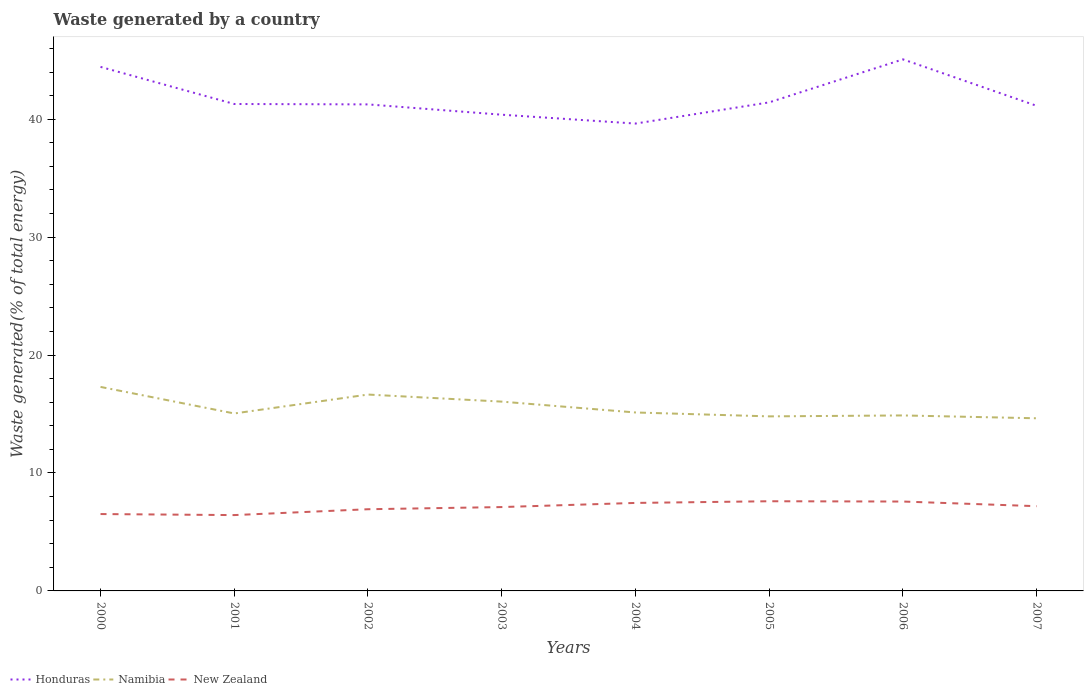How many different coloured lines are there?
Provide a succinct answer. 3. Is the number of lines equal to the number of legend labels?
Keep it short and to the point. Yes. Across all years, what is the maximum total waste generated in Honduras?
Offer a very short reply. 39.63. What is the total total waste generated in New Zealand in the graph?
Your response must be concise. -0.68. What is the difference between the highest and the second highest total waste generated in Honduras?
Ensure brevity in your answer.  5.44. What is the difference between the highest and the lowest total waste generated in Honduras?
Your answer should be very brief. 2. What is the difference between two consecutive major ticks on the Y-axis?
Offer a very short reply. 10. How are the legend labels stacked?
Your response must be concise. Horizontal. What is the title of the graph?
Make the answer very short. Waste generated by a country. Does "Marshall Islands" appear as one of the legend labels in the graph?
Your answer should be compact. No. What is the label or title of the X-axis?
Your response must be concise. Years. What is the label or title of the Y-axis?
Make the answer very short. Waste generated(% of total energy). What is the Waste generated(% of total energy) in Honduras in 2000?
Provide a succinct answer. 44.44. What is the Waste generated(% of total energy) of Namibia in 2000?
Provide a succinct answer. 17.3. What is the Waste generated(% of total energy) of New Zealand in 2000?
Your response must be concise. 6.52. What is the Waste generated(% of total energy) of Honduras in 2001?
Provide a succinct answer. 41.29. What is the Waste generated(% of total energy) of Namibia in 2001?
Offer a very short reply. 15.05. What is the Waste generated(% of total energy) in New Zealand in 2001?
Your response must be concise. 6.43. What is the Waste generated(% of total energy) of Honduras in 2002?
Give a very brief answer. 41.26. What is the Waste generated(% of total energy) of Namibia in 2002?
Make the answer very short. 16.65. What is the Waste generated(% of total energy) of New Zealand in 2002?
Ensure brevity in your answer.  6.93. What is the Waste generated(% of total energy) of Honduras in 2003?
Ensure brevity in your answer.  40.38. What is the Waste generated(% of total energy) of Namibia in 2003?
Your answer should be compact. 16.05. What is the Waste generated(% of total energy) of New Zealand in 2003?
Make the answer very short. 7.11. What is the Waste generated(% of total energy) in Honduras in 2004?
Ensure brevity in your answer.  39.63. What is the Waste generated(% of total energy) of Namibia in 2004?
Provide a succinct answer. 15.13. What is the Waste generated(% of total energy) in New Zealand in 2004?
Provide a succinct answer. 7.46. What is the Waste generated(% of total energy) in Honduras in 2005?
Offer a terse response. 41.43. What is the Waste generated(% of total energy) in Namibia in 2005?
Provide a short and direct response. 14.8. What is the Waste generated(% of total energy) of New Zealand in 2005?
Your answer should be very brief. 7.6. What is the Waste generated(% of total energy) of Honduras in 2006?
Keep it short and to the point. 45.07. What is the Waste generated(% of total energy) in Namibia in 2006?
Offer a terse response. 14.88. What is the Waste generated(% of total energy) in New Zealand in 2006?
Your answer should be compact. 7.58. What is the Waste generated(% of total energy) of Honduras in 2007?
Keep it short and to the point. 41.13. What is the Waste generated(% of total energy) of Namibia in 2007?
Provide a short and direct response. 14.64. What is the Waste generated(% of total energy) in New Zealand in 2007?
Your answer should be very brief. 7.19. Across all years, what is the maximum Waste generated(% of total energy) in Honduras?
Your response must be concise. 45.07. Across all years, what is the maximum Waste generated(% of total energy) of Namibia?
Your response must be concise. 17.3. Across all years, what is the maximum Waste generated(% of total energy) in New Zealand?
Offer a very short reply. 7.6. Across all years, what is the minimum Waste generated(% of total energy) in Honduras?
Provide a succinct answer. 39.63. Across all years, what is the minimum Waste generated(% of total energy) in Namibia?
Give a very brief answer. 14.64. Across all years, what is the minimum Waste generated(% of total energy) in New Zealand?
Offer a terse response. 6.43. What is the total Waste generated(% of total energy) of Honduras in the graph?
Provide a short and direct response. 334.63. What is the total Waste generated(% of total energy) of Namibia in the graph?
Your answer should be very brief. 124.5. What is the total Waste generated(% of total energy) of New Zealand in the graph?
Keep it short and to the point. 56.82. What is the difference between the Waste generated(% of total energy) of Honduras in 2000 and that in 2001?
Your response must be concise. 3.15. What is the difference between the Waste generated(% of total energy) in Namibia in 2000 and that in 2001?
Make the answer very short. 2.25. What is the difference between the Waste generated(% of total energy) of New Zealand in 2000 and that in 2001?
Provide a short and direct response. 0.09. What is the difference between the Waste generated(% of total energy) in Honduras in 2000 and that in 2002?
Offer a very short reply. 3.18. What is the difference between the Waste generated(% of total energy) in Namibia in 2000 and that in 2002?
Offer a very short reply. 0.65. What is the difference between the Waste generated(% of total energy) of New Zealand in 2000 and that in 2002?
Provide a short and direct response. -0.41. What is the difference between the Waste generated(% of total energy) of Honduras in 2000 and that in 2003?
Offer a terse response. 4.05. What is the difference between the Waste generated(% of total energy) in Namibia in 2000 and that in 2003?
Offer a very short reply. 1.25. What is the difference between the Waste generated(% of total energy) in New Zealand in 2000 and that in 2003?
Your response must be concise. -0.59. What is the difference between the Waste generated(% of total energy) in Honduras in 2000 and that in 2004?
Your answer should be very brief. 4.81. What is the difference between the Waste generated(% of total energy) in Namibia in 2000 and that in 2004?
Offer a terse response. 2.17. What is the difference between the Waste generated(% of total energy) of New Zealand in 2000 and that in 2004?
Your response must be concise. -0.94. What is the difference between the Waste generated(% of total energy) in Honduras in 2000 and that in 2005?
Provide a short and direct response. 3.01. What is the difference between the Waste generated(% of total energy) in Namibia in 2000 and that in 2005?
Provide a short and direct response. 2.5. What is the difference between the Waste generated(% of total energy) in New Zealand in 2000 and that in 2005?
Offer a terse response. -1.09. What is the difference between the Waste generated(% of total energy) of Honduras in 2000 and that in 2006?
Your answer should be compact. -0.64. What is the difference between the Waste generated(% of total energy) of Namibia in 2000 and that in 2006?
Your answer should be compact. 2.42. What is the difference between the Waste generated(% of total energy) of New Zealand in 2000 and that in 2006?
Ensure brevity in your answer.  -1.06. What is the difference between the Waste generated(% of total energy) in Honduras in 2000 and that in 2007?
Provide a short and direct response. 3.3. What is the difference between the Waste generated(% of total energy) of Namibia in 2000 and that in 2007?
Offer a terse response. 2.66. What is the difference between the Waste generated(% of total energy) of New Zealand in 2000 and that in 2007?
Give a very brief answer. -0.67. What is the difference between the Waste generated(% of total energy) in Honduras in 2001 and that in 2002?
Ensure brevity in your answer.  0.03. What is the difference between the Waste generated(% of total energy) of Namibia in 2001 and that in 2002?
Ensure brevity in your answer.  -1.6. What is the difference between the Waste generated(% of total energy) of New Zealand in 2001 and that in 2002?
Your response must be concise. -0.5. What is the difference between the Waste generated(% of total energy) in Honduras in 2001 and that in 2003?
Make the answer very short. 0.91. What is the difference between the Waste generated(% of total energy) of Namibia in 2001 and that in 2003?
Your answer should be compact. -1. What is the difference between the Waste generated(% of total energy) of New Zealand in 2001 and that in 2003?
Provide a succinct answer. -0.68. What is the difference between the Waste generated(% of total energy) of Honduras in 2001 and that in 2004?
Keep it short and to the point. 1.66. What is the difference between the Waste generated(% of total energy) of Namibia in 2001 and that in 2004?
Keep it short and to the point. -0.08. What is the difference between the Waste generated(% of total energy) in New Zealand in 2001 and that in 2004?
Make the answer very short. -1.03. What is the difference between the Waste generated(% of total energy) in Honduras in 2001 and that in 2005?
Ensure brevity in your answer.  -0.14. What is the difference between the Waste generated(% of total energy) of Namibia in 2001 and that in 2005?
Offer a terse response. 0.25. What is the difference between the Waste generated(% of total energy) of New Zealand in 2001 and that in 2005?
Offer a very short reply. -1.17. What is the difference between the Waste generated(% of total energy) of Honduras in 2001 and that in 2006?
Keep it short and to the point. -3.78. What is the difference between the Waste generated(% of total energy) in Namibia in 2001 and that in 2006?
Your response must be concise. 0.17. What is the difference between the Waste generated(% of total energy) of New Zealand in 2001 and that in 2006?
Provide a short and direct response. -1.15. What is the difference between the Waste generated(% of total energy) in Honduras in 2001 and that in 2007?
Give a very brief answer. 0.16. What is the difference between the Waste generated(% of total energy) of Namibia in 2001 and that in 2007?
Keep it short and to the point. 0.41. What is the difference between the Waste generated(% of total energy) in New Zealand in 2001 and that in 2007?
Offer a very short reply. -0.76. What is the difference between the Waste generated(% of total energy) of Honduras in 2002 and that in 2003?
Provide a succinct answer. 0.87. What is the difference between the Waste generated(% of total energy) of Namibia in 2002 and that in 2003?
Provide a short and direct response. 0.6. What is the difference between the Waste generated(% of total energy) in New Zealand in 2002 and that in 2003?
Give a very brief answer. -0.18. What is the difference between the Waste generated(% of total energy) in Honduras in 2002 and that in 2004?
Your response must be concise. 1.63. What is the difference between the Waste generated(% of total energy) in Namibia in 2002 and that in 2004?
Provide a short and direct response. 1.52. What is the difference between the Waste generated(% of total energy) in New Zealand in 2002 and that in 2004?
Offer a very short reply. -0.53. What is the difference between the Waste generated(% of total energy) in Honduras in 2002 and that in 2005?
Ensure brevity in your answer.  -0.17. What is the difference between the Waste generated(% of total energy) in Namibia in 2002 and that in 2005?
Offer a terse response. 1.85. What is the difference between the Waste generated(% of total energy) in New Zealand in 2002 and that in 2005?
Keep it short and to the point. -0.68. What is the difference between the Waste generated(% of total energy) in Honduras in 2002 and that in 2006?
Offer a very short reply. -3.82. What is the difference between the Waste generated(% of total energy) of Namibia in 2002 and that in 2006?
Provide a succinct answer. 1.77. What is the difference between the Waste generated(% of total energy) of New Zealand in 2002 and that in 2006?
Provide a short and direct response. -0.65. What is the difference between the Waste generated(% of total energy) in Honduras in 2002 and that in 2007?
Provide a short and direct response. 0.12. What is the difference between the Waste generated(% of total energy) in Namibia in 2002 and that in 2007?
Keep it short and to the point. 2.01. What is the difference between the Waste generated(% of total energy) in New Zealand in 2002 and that in 2007?
Ensure brevity in your answer.  -0.26. What is the difference between the Waste generated(% of total energy) of Honduras in 2003 and that in 2004?
Offer a very short reply. 0.75. What is the difference between the Waste generated(% of total energy) of Namibia in 2003 and that in 2004?
Offer a very short reply. 0.92. What is the difference between the Waste generated(% of total energy) in New Zealand in 2003 and that in 2004?
Your answer should be compact. -0.35. What is the difference between the Waste generated(% of total energy) of Honduras in 2003 and that in 2005?
Make the answer very short. -1.05. What is the difference between the Waste generated(% of total energy) in Namibia in 2003 and that in 2005?
Provide a succinct answer. 1.25. What is the difference between the Waste generated(% of total energy) of New Zealand in 2003 and that in 2005?
Make the answer very short. -0.49. What is the difference between the Waste generated(% of total energy) of Honduras in 2003 and that in 2006?
Your answer should be very brief. -4.69. What is the difference between the Waste generated(% of total energy) in Namibia in 2003 and that in 2006?
Your answer should be compact. 1.17. What is the difference between the Waste generated(% of total energy) of New Zealand in 2003 and that in 2006?
Your answer should be very brief. -0.47. What is the difference between the Waste generated(% of total energy) of Honduras in 2003 and that in 2007?
Give a very brief answer. -0.75. What is the difference between the Waste generated(% of total energy) in Namibia in 2003 and that in 2007?
Your response must be concise. 1.41. What is the difference between the Waste generated(% of total energy) in New Zealand in 2003 and that in 2007?
Ensure brevity in your answer.  -0.07. What is the difference between the Waste generated(% of total energy) of Honduras in 2004 and that in 2005?
Your answer should be compact. -1.8. What is the difference between the Waste generated(% of total energy) of Namibia in 2004 and that in 2005?
Your response must be concise. 0.33. What is the difference between the Waste generated(% of total energy) of New Zealand in 2004 and that in 2005?
Keep it short and to the point. -0.14. What is the difference between the Waste generated(% of total energy) in Honduras in 2004 and that in 2006?
Keep it short and to the point. -5.44. What is the difference between the Waste generated(% of total energy) in Namibia in 2004 and that in 2006?
Make the answer very short. 0.25. What is the difference between the Waste generated(% of total energy) in New Zealand in 2004 and that in 2006?
Offer a terse response. -0.12. What is the difference between the Waste generated(% of total energy) in Honduras in 2004 and that in 2007?
Make the answer very short. -1.5. What is the difference between the Waste generated(% of total energy) of Namibia in 2004 and that in 2007?
Your answer should be very brief. 0.49. What is the difference between the Waste generated(% of total energy) in New Zealand in 2004 and that in 2007?
Provide a succinct answer. 0.28. What is the difference between the Waste generated(% of total energy) in Honduras in 2005 and that in 2006?
Keep it short and to the point. -3.65. What is the difference between the Waste generated(% of total energy) of Namibia in 2005 and that in 2006?
Offer a terse response. -0.08. What is the difference between the Waste generated(% of total energy) of New Zealand in 2005 and that in 2006?
Keep it short and to the point. 0.02. What is the difference between the Waste generated(% of total energy) in Honduras in 2005 and that in 2007?
Provide a succinct answer. 0.29. What is the difference between the Waste generated(% of total energy) of Namibia in 2005 and that in 2007?
Your answer should be compact. 0.16. What is the difference between the Waste generated(% of total energy) of New Zealand in 2005 and that in 2007?
Ensure brevity in your answer.  0.42. What is the difference between the Waste generated(% of total energy) of Honduras in 2006 and that in 2007?
Ensure brevity in your answer.  3.94. What is the difference between the Waste generated(% of total energy) of Namibia in 2006 and that in 2007?
Make the answer very short. 0.24. What is the difference between the Waste generated(% of total energy) in New Zealand in 2006 and that in 2007?
Keep it short and to the point. 0.39. What is the difference between the Waste generated(% of total energy) of Honduras in 2000 and the Waste generated(% of total energy) of Namibia in 2001?
Make the answer very short. 29.39. What is the difference between the Waste generated(% of total energy) of Honduras in 2000 and the Waste generated(% of total energy) of New Zealand in 2001?
Your answer should be compact. 38.01. What is the difference between the Waste generated(% of total energy) in Namibia in 2000 and the Waste generated(% of total energy) in New Zealand in 2001?
Your answer should be compact. 10.87. What is the difference between the Waste generated(% of total energy) of Honduras in 2000 and the Waste generated(% of total energy) of Namibia in 2002?
Offer a terse response. 27.78. What is the difference between the Waste generated(% of total energy) in Honduras in 2000 and the Waste generated(% of total energy) in New Zealand in 2002?
Your answer should be compact. 37.51. What is the difference between the Waste generated(% of total energy) in Namibia in 2000 and the Waste generated(% of total energy) in New Zealand in 2002?
Make the answer very short. 10.37. What is the difference between the Waste generated(% of total energy) in Honduras in 2000 and the Waste generated(% of total energy) in Namibia in 2003?
Offer a terse response. 28.38. What is the difference between the Waste generated(% of total energy) of Honduras in 2000 and the Waste generated(% of total energy) of New Zealand in 2003?
Your answer should be compact. 37.33. What is the difference between the Waste generated(% of total energy) in Namibia in 2000 and the Waste generated(% of total energy) in New Zealand in 2003?
Give a very brief answer. 10.19. What is the difference between the Waste generated(% of total energy) in Honduras in 2000 and the Waste generated(% of total energy) in Namibia in 2004?
Make the answer very short. 29.3. What is the difference between the Waste generated(% of total energy) of Honduras in 2000 and the Waste generated(% of total energy) of New Zealand in 2004?
Make the answer very short. 36.97. What is the difference between the Waste generated(% of total energy) in Namibia in 2000 and the Waste generated(% of total energy) in New Zealand in 2004?
Make the answer very short. 9.84. What is the difference between the Waste generated(% of total energy) in Honduras in 2000 and the Waste generated(% of total energy) in Namibia in 2005?
Give a very brief answer. 29.64. What is the difference between the Waste generated(% of total energy) of Honduras in 2000 and the Waste generated(% of total energy) of New Zealand in 2005?
Provide a short and direct response. 36.83. What is the difference between the Waste generated(% of total energy) of Namibia in 2000 and the Waste generated(% of total energy) of New Zealand in 2005?
Offer a terse response. 9.7. What is the difference between the Waste generated(% of total energy) of Honduras in 2000 and the Waste generated(% of total energy) of Namibia in 2006?
Your response must be concise. 29.56. What is the difference between the Waste generated(% of total energy) in Honduras in 2000 and the Waste generated(% of total energy) in New Zealand in 2006?
Make the answer very short. 36.86. What is the difference between the Waste generated(% of total energy) of Namibia in 2000 and the Waste generated(% of total energy) of New Zealand in 2006?
Offer a very short reply. 9.72. What is the difference between the Waste generated(% of total energy) in Honduras in 2000 and the Waste generated(% of total energy) in Namibia in 2007?
Provide a succinct answer. 29.8. What is the difference between the Waste generated(% of total energy) of Honduras in 2000 and the Waste generated(% of total energy) of New Zealand in 2007?
Your answer should be very brief. 37.25. What is the difference between the Waste generated(% of total energy) of Namibia in 2000 and the Waste generated(% of total energy) of New Zealand in 2007?
Your answer should be compact. 10.11. What is the difference between the Waste generated(% of total energy) in Honduras in 2001 and the Waste generated(% of total energy) in Namibia in 2002?
Your answer should be very brief. 24.64. What is the difference between the Waste generated(% of total energy) in Honduras in 2001 and the Waste generated(% of total energy) in New Zealand in 2002?
Provide a short and direct response. 34.36. What is the difference between the Waste generated(% of total energy) of Namibia in 2001 and the Waste generated(% of total energy) of New Zealand in 2002?
Offer a terse response. 8.12. What is the difference between the Waste generated(% of total energy) of Honduras in 2001 and the Waste generated(% of total energy) of Namibia in 2003?
Your answer should be compact. 25.24. What is the difference between the Waste generated(% of total energy) in Honduras in 2001 and the Waste generated(% of total energy) in New Zealand in 2003?
Ensure brevity in your answer.  34.18. What is the difference between the Waste generated(% of total energy) in Namibia in 2001 and the Waste generated(% of total energy) in New Zealand in 2003?
Provide a succinct answer. 7.94. What is the difference between the Waste generated(% of total energy) in Honduras in 2001 and the Waste generated(% of total energy) in Namibia in 2004?
Give a very brief answer. 26.16. What is the difference between the Waste generated(% of total energy) in Honduras in 2001 and the Waste generated(% of total energy) in New Zealand in 2004?
Ensure brevity in your answer.  33.83. What is the difference between the Waste generated(% of total energy) in Namibia in 2001 and the Waste generated(% of total energy) in New Zealand in 2004?
Provide a short and direct response. 7.59. What is the difference between the Waste generated(% of total energy) in Honduras in 2001 and the Waste generated(% of total energy) in Namibia in 2005?
Your answer should be very brief. 26.49. What is the difference between the Waste generated(% of total energy) of Honduras in 2001 and the Waste generated(% of total energy) of New Zealand in 2005?
Offer a very short reply. 33.69. What is the difference between the Waste generated(% of total energy) in Namibia in 2001 and the Waste generated(% of total energy) in New Zealand in 2005?
Your answer should be compact. 7.44. What is the difference between the Waste generated(% of total energy) in Honduras in 2001 and the Waste generated(% of total energy) in Namibia in 2006?
Your response must be concise. 26.41. What is the difference between the Waste generated(% of total energy) of Honduras in 2001 and the Waste generated(% of total energy) of New Zealand in 2006?
Give a very brief answer. 33.71. What is the difference between the Waste generated(% of total energy) in Namibia in 2001 and the Waste generated(% of total energy) in New Zealand in 2006?
Keep it short and to the point. 7.47. What is the difference between the Waste generated(% of total energy) of Honduras in 2001 and the Waste generated(% of total energy) of Namibia in 2007?
Your answer should be compact. 26.65. What is the difference between the Waste generated(% of total energy) in Honduras in 2001 and the Waste generated(% of total energy) in New Zealand in 2007?
Your response must be concise. 34.1. What is the difference between the Waste generated(% of total energy) in Namibia in 2001 and the Waste generated(% of total energy) in New Zealand in 2007?
Keep it short and to the point. 7.86. What is the difference between the Waste generated(% of total energy) of Honduras in 2002 and the Waste generated(% of total energy) of Namibia in 2003?
Keep it short and to the point. 25.2. What is the difference between the Waste generated(% of total energy) in Honduras in 2002 and the Waste generated(% of total energy) in New Zealand in 2003?
Your answer should be very brief. 34.15. What is the difference between the Waste generated(% of total energy) in Namibia in 2002 and the Waste generated(% of total energy) in New Zealand in 2003?
Ensure brevity in your answer.  9.54. What is the difference between the Waste generated(% of total energy) in Honduras in 2002 and the Waste generated(% of total energy) in Namibia in 2004?
Offer a very short reply. 26.12. What is the difference between the Waste generated(% of total energy) in Honduras in 2002 and the Waste generated(% of total energy) in New Zealand in 2004?
Offer a terse response. 33.79. What is the difference between the Waste generated(% of total energy) of Namibia in 2002 and the Waste generated(% of total energy) of New Zealand in 2004?
Provide a succinct answer. 9.19. What is the difference between the Waste generated(% of total energy) in Honduras in 2002 and the Waste generated(% of total energy) in Namibia in 2005?
Ensure brevity in your answer.  26.45. What is the difference between the Waste generated(% of total energy) in Honduras in 2002 and the Waste generated(% of total energy) in New Zealand in 2005?
Make the answer very short. 33.65. What is the difference between the Waste generated(% of total energy) in Namibia in 2002 and the Waste generated(% of total energy) in New Zealand in 2005?
Your response must be concise. 9.05. What is the difference between the Waste generated(% of total energy) in Honduras in 2002 and the Waste generated(% of total energy) in Namibia in 2006?
Ensure brevity in your answer.  26.38. What is the difference between the Waste generated(% of total energy) in Honduras in 2002 and the Waste generated(% of total energy) in New Zealand in 2006?
Give a very brief answer. 33.68. What is the difference between the Waste generated(% of total energy) in Namibia in 2002 and the Waste generated(% of total energy) in New Zealand in 2006?
Keep it short and to the point. 9.07. What is the difference between the Waste generated(% of total energy) in Honduras in 2002 and the Waste generated(% of total energy) in Namibia in 2007?
Offer a terse response. 26.62. What is the difference between the Waste generated(% of total energy) in Honduras in 2002 and the Waste generated(% of total energy) in New Zealand in 2007?
Ensure brevity in your answer.  34.07. What is the difference between the Waste generated(% of total energy) in Namibia in 2002 and the Waste generated(% of total energy) in New Zealand in 2007?
Provide a succinct answer. 9.47. What is the difference between the Waste generated(% of total energy) in Honduras in 2003 and the Waste generated(% of total energy) in Namibia in 2004?
Offer a terse response. 25.25. What is the difference between the Waste generated(% of total energy) in Honduras in 2003 and the Waste generated(% of total energy) in New Zealand in 2004?
Offer a terse response. 32.92. What is the difference between the Waste generated(% of total energy) in Namibia in 2003 and the Waste generated(% of total energy) in New Zealand in 2004?
Provide a short and direct response. 8.59. What is the difference between the Waste generated(% of total energy) of Honduras in 2003 and the Waste generated(% of total energy) of Namibia in 2005?
Ensure brevity in your answer.  25.58. What is the difference between the Waste generated(% of total energy) of Honduras in 2003 and the Waste generated(% of total energy) of New Zealand in 2005?
Provide a succinct answer. 32.78. What is the difference between the Waste generated(% of total energy) of Namibia in 2003 and the Waste generated(% of total energy) of New Zealand in 2005?
Give a very brief answer. 8.45. What is the difference between the Waste generated(% of total energy) of Honduras in 2003 and the Waste generated(% of total energy) of Namibia in 2006?
Offer a very short reply. 25.5. What is the difference between the Waste generated(% of total energy) in Honduras in 2003 and the Waste generated(% of total energy) in New Zealand in 2006?
Offer a very short reply. 32.8. What is the difference between the Waste generated(% of total energy) in Namibia in 2003 and the Waste generated(% of total energy) in New Zealand in 2006?
Your response must be concise. 8.47. What is the difference between the Waste generated(% of total energy) of Honduras in 2003 and the Waste generated(% of total energy) of Namibia in 2007?
Your response must be concise. 25.74. What is the difference between the Waste generated(% of total energy) in Honduras in 2003 and the Waste generated(% of total energy) in New Zealand in 2007?
Ensure brevity in your answer.  33.2. What is the difference between the Waste generated(% of total energy) in Namibia in 2003 and the Waste generated(% of total energy) in New Zealand in 2007?
Give a very brief answer. 8.87. What is the difference between the Waste generated(% of total energy) of Honduras in 2004 and the Waste generated(% of total energy) of Namibia in 2005?
Give a very brief answer. 24.83. What is the difference between the Waste generated(% of total energy) in Honduras in 2004 and the Waste generated(% of total energy) in New Zealand in 2005?
Provide a short and direct response. 32.03. What is the difference between the Waste generated(% of total energy) in Namibia in 2004 and the Waste generated(% of total energy) in New Zealand in 2005?
Ensure brevity in your answer.  7.53. What is the difference between the Waste generated(% of total energy) of Honduras in 2004 and the Waste generated(% of total energy) of Namibia in 2006?
Provide a short and direct response. 24.75. What is the difference between the Waste generated(% of total energy) of Honduras in 2004 and the Waste generated(% of total energy) of New Zealand in 2006?
Offer a terse response. 32.05. What is the difference between the Waste generated(% of total energy) of Namibia in 2004 and the Waste generated(% of total energy) of New Zealand in 2006?
Your response must be concise. 7.55. What is the difference between the Waste generated(% of total energy) in Honduras in 2004 and the Waste generated(% of total energy) in Namibia in 2007?
Your answer should be compact. 24.99. What is the difference between the Waste generated(% of total energy) in Honduras in 2004 and the Waste generated(% of total energy) in New Zealand in 2007?
Make the answer very short. 32.44. What is the difference between the Waste generated(% of total energy) of Namibia in 2004 and the Waste generated(% of total energy) of New Zealand in 2007?
Ensure brevity in your answer.  7.95. What is the difference between the Waste generated(% of total energy) in Honduras in 2005 and the Waste generated(% of total energy) in Namibia in 2006?
Keep it short and to the point. 26.55. What is the difference between the Waste generated(% of total energy) of Honduras in 2005 and the Waste generated(% of total energy) of New Zealand in 2006?
Provide a short and direct response. 33.85. What is the difference between the Waste generated(% of total energy) of Namibia in 2005 and the Waste generated(% of total energy) of New Zealand in 2006?
Offer a terse response. 7.22. What is the difference between the Waste generated(% of total energy) of Honduras in 2005 and the Waste generated(% of total energy) of Namibia in 2007?
Your response must be concise. 26.79. What is the difference between the Waste generated(% of total energy) of Honduras in 2005 and the Waste generated(% of total energy) of New Zealand in 2007?
Ensure brevity in your answer.  34.24. What is the difference between the Waste generated(% of total energy) of Namibia in 2005 and the Waste generated(% of total energy) of New Zealand in 2007?
Make the answer very short. 7.62. What is the difference between the Waste generated(% of total energy) in Honduras in 2006 and the Waste generated(% of total energy) in Namibia in 2007?
Make the answer very short. 30.44. What is the difference between the Waste generated(% of total energy) in Honduras in 2006 and the Waste generated(% of total energy) in New Zealand in 2007?
Your response must be concise. 37.89. What is the difference between the Waste generated(% of total energy) in Namibia in 2006 and the Waste generated(% of total energy) in New Zealand in 2007?
Keep it short and to the point. 7.69. What is the average Waste generated(% of total energy) in Honduras per year?
Your answer should be very brief. 41.83. What is the average Waste generated(% of total energy) of Namibia per year?
Your answer should be very brief. 15.56. What is the average Waste generated(% of total energy) of New Zealand per year?
Keep it short and to the point. 7.1. In the year 2000, what is the difference between the Waste generated(% of total energy) of Honduras and Waste generated(% of total energy) of Namibia?
Provide a short and direct response. 27.14. In the year 2000, what is the difference between the Waste generated(% of total energy) of Honduras and Waste generated(% of total energy) of New Zealand?
Your answer should be compact. 37.92. In the year 2000, what is the difference between the Waste generated(% of total energy) of Namibia and Waste generated(% of total energy) of New Zealand?
Your response must be concise. 10.78. In the year 2001, what is the difference between the Waste generated(% of total energy) of Honduras and Waste generated(% of total energy) of Namibia?
Provide a succinct answer. 26.24. In the year 2001, what is the difference between the Waste generated(% of total energy) of Honduras and Waste generated(% of total energy) of New Zealand?
Keep it short and to the point. 34.86. In the year 2001, what is the difference between the Waste generated(% of total energy) in Namibia and Waste generated(% of total energy) in New Zealand?
Your answer should be very brief. 8.62. In the year 2002, what is the difference between the Waste generated(% of total energy) of Honduras and Waste generated(% of total energy) of Namibia?
Your response must be concise. 24.6. In the year 2002, what is the difference between the Waste generated(% of total energy) in Honduras and Waste generated(% of total energy) in New Zealand?
Offer a very short reply. 34.33. In the year 2002, what is the difference between the Waste generated(% of total energy) in Namibia and Waste generated(% of total energy) in New Zealand?
Provide a short and direct response. 9.72. In the year 2003, what is the difference between the Waste generated(% of total energy) in Honduras and Waste generated(% of total energy) in Namibia?
Your answer should be compact. 24.33. In the year 2003, what is the difference between the Waste generated(% of total energy) in Honduras and Waste generated(% of total energy) in New Zealand?
Provide a succinct answer. 33.27. In the year 2003, what is the difference between the Waste generated(% of total energy) in Namibia and Waste generated(% of total energy) in New Zealand?
Provide a succinct answer. 8.94. In the year 2004, what is the difference between the Waste generated(% of total energy) of Honduras and Waste generated(% of total energy) of Namibia?
Your response must be concise. 24.5. In the year 2004, what is the difference between the Waste generated(% of total energy) of Honduras and Waste generated(% of total energy) of New Zealand?
Make the answer very short. 32.17. In the year 2004, what is the difference between the Waste generated(% of total energy) of Namibia and Waste generated(% of total energy) of New Zealand?
Your answer should be compact. 7.67. In the year 2005, what is the difference between the Waste generated(% of total energy) in Honduras and Waste generated(% of total energy) in Namibia?
Provide a succinct answer. 26.63. In the year 2005, what is the difference between the Waste generated(% of total energy) of Honduras and Waste generated(% of total energy) of New Zealand?
Your response must be concise. 33.82. In the year 2005, what is the difference between the Waste generated(% of total energy) in Namibia and Waste generated(% of total energy) in New Zealand?
Your response must be concise. 7.2. In the year 2006, what is the difference between the Waste generated(% of total energy) of Honduras and Waste generated(% of total energy) of Namibia?
Offer a terse response. 30.19. In the year 2006, what is the difference between the Waste generated(% of total energy) of Honduras and Waste generated(% of total energy) of New Zealand?
Provide a succinct answer. 37.49. In the year 2006, what is the difference between the Waste generated(% of total energy) of Namibia and Waste generated(% of total energy) of New Zealand?
Make the answer very short. 7.3. In the year 2007, what is the difference between the Waste generated(% of total energy) in Honduras and Waste generated(% of total energy) in Namibia?
Offer a very short reply. 26.5. In the year 2007, what is the difference between the Waste generated(% of total energy) in Honduras and Waste generated(% of total energy) in New Zealand?
Provide a short and direct response. 33.95. In the year 2007, what is the difference between the Waste generated(% of total energy) of Namibia and Waste generated(% of total energy) of New Zealand?
Give a very brief answer. 7.45. What is the ratio of the Waste generated(% of total energy) in Honduras in 2000 to that in 2001?
Your answer should be very brief. 1.08. What is the ratio of the Waste generated(% of total energy) in Namibia in 2000 to that in 2001?
Keep it short and to the point. 1.15. What is the ratio of the Waste generated(% of total energy) of New Zealand in 2000 to that in 2001?
Your answer should be compact. 1.01. What is the ratio of the Waste generated(% of total energy) of Honduras in 2000 to that in 2002?
Give a very brief answer. 1.08. What is the ratio of the Waste generated(% of total energy) in Namibia in 2000 to that in 2002?
Provide a succinct answer. 1.04. What is the ratio of the Waste generated(% of total energy) in New Zealand in 2000 to that in 2002?
Keep it short and to the point. 0.94. What is the ratio of the Waste generated(% of total energy) of Honduras in 2000 to that in 2003?
Provide a succinct answer. 1.1. What is the ratio of the Waste generated(% of total energy) in Namibia in 2000 to that in 2003?
Your answer should be very brief. 1.08. What is the ratio of the Waste generated(% of total energy) in Honduras in 2000 to that in 2004?
Keep it short and to the point. 1.12. What is the ratio of the Waste generated(% of total energy) of Namibia in 2000 to that in 2004?
Ensure brevity in your answer.  1.14. What is the ratio of the Waste generated(% of total energy) of New Zealand in 2000 to that in 2004?
Provide a short and direct response. 0.87. What is the ratio of the Waste generated(% of total energy) of Honduras in 2000 to that in 2005?
Make the answer very short. 1.07. What is the ratio of the Waste generated(% of total energy) in Namibia in 2000 to that in 2005?
Your answer should be compact. 1.17. What is the ratio of the Waste generated(% of total energy) of New Zealand in 2000 to that in 2005?
Ensure brevity in your answer.  0.86. What is the ratio of the Waste generated(% of total energy) of Honduras in 2000 to that in 2006?
Provide a short and direct response. 0.99. What is the ratio of the Waste generated(% of total energy) of Namibia in 2000 to that in 2006?
Keep it short and to the point. 1.16. What is the ratio of the Waste generated(% of total energy) in New Zealand in 2000 to that in 2006?
Offer a very short reply. 0.86. What is the ratio of the Waste generated(% of total energy) in Honduras in 2000 to that in 2007?
Offer a very short reply. 1.08. What is the ratio of the Waste generated(% of total energy) of Namibia in 2000 to that in 2007?
Provide a succinct answer. 1.18. What is the ratio of the Waste generated(% of total energy) in New Zealand in 2000 to that in 2007?
Make the answer very short. 0.91. What is the ratio of the Waste generated(% of total energy) of Honduras in 2001 to that in 2002?
Offer a terse response. 1. What is the ratio of the Waste generated(% of total energy) in Namibia in 2001 to that in 2002?
Your answer should be compact. 0.9. What is the ratio of the Waste generated(% of total energy) in New Zealand in 2001 to that in 2002?
Keep it short and to the point. 0.93. What is the ratio of the Waste generated(% of total energy) of Honduras in 2001 to that in 2003?
Provide a short and direct response. 1.02. What is the ratio of the Waste generated(% of total energy) of Namibia in 2001 to that in 2003?
Your answer should be compact. 0.94. What is the ratio of the Waste generated(% of total energy) of New Zealand in 2001 to that in 2003?
Offer a terse response. 0.9. What is the ratio of the Waste generated(% of total energy) of Honduras in 2001 to that in 2004?
Ensure brevity in your answer.  1.04. What is the ratio of the Waste generated(% of total energy) in New Zealand in 2001 to that in 2004?
Ensure brevity in your answer.  0.86. What is the ratio of the Waste generated(% of total energy) of Namibia in 2001 to that in 2005?
Keep it short and to the point. 1.02. What is the ratio of the Waste generated(% of total energy) in New Zealand in 2001 to that in 2005?
Your answer should be compact. 0.85. What is the ratio of the Waste generated(% of total energy) of Honduras in 2001 to that in 2006?
Provide a short and direct response. 0.92. What is the ratio of the Waste generated(% of total energy) in Namibia in 2001 to that in 2006?
Provide a succinct answer. 1.01. What is the ratio of the Waste generated(% of total energy) in New Zealand in 2001 to that in 2006?
Make the answer very short. 0.85. What is the ratio of the Waste generated(% of total energy) in Namibia in 2001 to that in 2007?
Offer a terse response. 1.03. What is the ratio of the Waste generated(% of total energy) in New Zealand in 2001 to that in 2007?
Your response must be concise. 0.89. What is the ratio of the Waste generated(% of total energy) of Honduras in 2002 to that in 2003?
Make the answer very short. 1.02. What is the ratio of the Waste generated(% of total energy) of Namibia in 2002 to that in 2003?
Your answer should be very brief. 1.04. What is the ratio of the Waste generated(% of total energy) of New Zealand in 2002 to that in 2003?
Give a very brief answer. 0.97. What is the ratio of the Waste generated(% of total energy) of Honduras in 2002 to that in 2004?
Your answer should be compact. 1.04. What is the ratio of the Waste generated(% of total energy) of Namibia in 2002 to that in 2004?
Provide a succinct answer. 1.1. What is the ratio of the Waste generated(% of total energy) of New Zealand in 2002 to that in 2004?
Your response must be concise. 0.93. What is the ratio of the Waste generated(% of total energy) of Honduras in 2002 to that in 2005?
Your response must be concise. 1. What is the ratio of the Waste generated(% of total energy) in New Zealand in 2002 to that in 2005?
Ensure brevity in your answer.  0.91. What is the ratio of the Waste generated(% of total energy) in Honduras in 2002 to that in 2006?
Make the answer very short. 0.92. What is the ratio of the Waste generated(% of total energy) in Namibia in 2002 to that in 2006?
Provide a succinct answer. 1.12. What is the ratio of the Waste generated(% of total energy) of New Zealand in 2002 to that in 2006?
Your response must be concise. 0.91. What is the ratio of the Waste generated(% of total energy) in Honduras in 2002 to that in 2007?
Ensure brevity in your answer.  1. What is the ratio of the Waste generated(% of total energy) in Namibia in 2002 to that in 2007?
Provide a succinct answer. 1.14. What is the ratio of the Waste generated(% of total energy) of Honduras in 2003 to that in 2004?
Your answer should be very brief. 1.02. What is the ratio of the Waste generated(% of total energy) in Namibia in 2003 to that in 2004?
Offer a terse response. 1.06. What is the ratio of the Waste generated(% of total energy) of New Zealand in 2003 to that in 2004?
Keep it short and to the point. 0.95. What is the ratio of the Waste generated(% of total energy) of Honduras in 2003 to that in 2005?
Offer a very short reply. 0.97. What is the ratio of the Waste generated(% of total energy) in Namibia in 2003 to that in 2005?
Make the answer very short. 1.08. What is the ratio of the Waste generated(% of total energy) of New Zealand in 2003 to that in 2005?
Offer a terse response. 0.94. What is the ratio of the Waste generated(% of total energy) of Honduras in 2003 to that in 2006?
Your response must be concise. 0.9. What is the ratio of the Waste generated(% of total energy) in Namibia in 2003 to that in 2006?
Make the answer very short. 1.08. What is the ratio of the Waste generated(% of total energy) in New Zealand in 2003 to that in 2006?
Your answer should be compact. 0.94. What is the ratio of the Waste generated(% of total energy) of Honduras in 2003 to that in 2007?
Offer a terse response. 0.98. What is the ratio of the Waste generated(% of total energy) of Namibia in 2003 to that in 2007?
Your answer should be compact. 1.1. What is the ratio of the Waste generated(% of total energy) of New Zealand in 2003 to that in 2007?
Ensure brevity in your answer.  0.99. What is the ratio of the Waste generated(% of total energy) in Honduras in 2004 to that in 2005?
Your response must be concise. 0.96. What is the ratio of the Waste generated(% of total energy) of Namibia in 2004 to that in 2005?
Your answer should be very brief. 1.02. What is the ratio of the Waste generated(% of total energy) of New Zealand in 2004 to that in 2005?
Keep it short and to the point. 0.98. What is the ratio of the Waste generated(% of total energy) of Honduras in 2004 to that in 2006?
Give a very brief answer. 0.88. What is the ratio of the Waste generated(% of total energy) of Namibia in 2004 to that in 2006?
Your answer should be very brief. 1.02. What is the ratio of the Waste generated(% of total energy) of New Zealand in 2004 to that in 2006?
Offer a terse response. 0.98. What is the ratio of the Waste generated(% of total energy) of Honduras in 2004 to that in 2007?
Keep it short and to the point. 0.96. What is the ratio of the Waste generated(% of total energy) in Namibia in 2004 to that in 2007?
Ensure brevity in your answer.  1.03. What is the ratio of the Waste generated(% of total energy) of New Zealand in 2004 to that in 2007?
Your answer should be compact. 1.04. What is the ratio of the Waste generated(% of total energy) in Honduras in 2005 to that in 2006?
Make the answer very short. 0.92. What is the ratio of the Waste generated(% of total energy) of New Zealand in 2005 to that in 2006?
Keep it short and to the point. 1. What is the ratio of the Waste generated(% of total energy) in Honduras in 2005 to that in 2007?
Make the answer very short. 1.01. What is the ratio of the Waste generated(% of total energy) in Namibia in 2005 to that in 2007?
Your response must be concise. 1.01. What is the ratio of the Waste generated(% of total energy) of New Zealand in 2005 to that in 2007?
Your answer should be very brief. 1.06. What is the ratio of the Waste generated(% of total energy) of Honduras in 2006 to that in 2007?
Your answer should be very brief. 1.1. What is the ratio of the Waste generated(% of total energy) of Namibia in 2006 to that in 2007?
Your answer should be compact. 1.02. What is the ratio of the Waste generated(% of total energy) of New Zealand in 2006 to that in 2007?
Provide a short and direct response. 1.05. What is the difference between the highest and the second highest Waste generated(% of total energy) in Honduras?
Your answer should be very brief. 0.64. What is the difference between the highest and the second highest Waste generated(% of total energy) of Namibia?
Give a very brief answer. 0.65. What is the difference between the highest and the second highest Waste generated(% of total energy) of New Zealand?
Your answer should be very brief. 0.02. What is the difference between the highest and the lowest Waste generated(% of total energy) in Honduras?
Provide a succinct answer. 5.44. What is the difference between the highest and the lowest Waste generated(% of total energy) of Namibia?
Provide a succinct answer. 2.66. What is the difference between the highest and the lowest Waste generated(% of total energy) in New Zealand?
Offer a terse response. 1.17. 